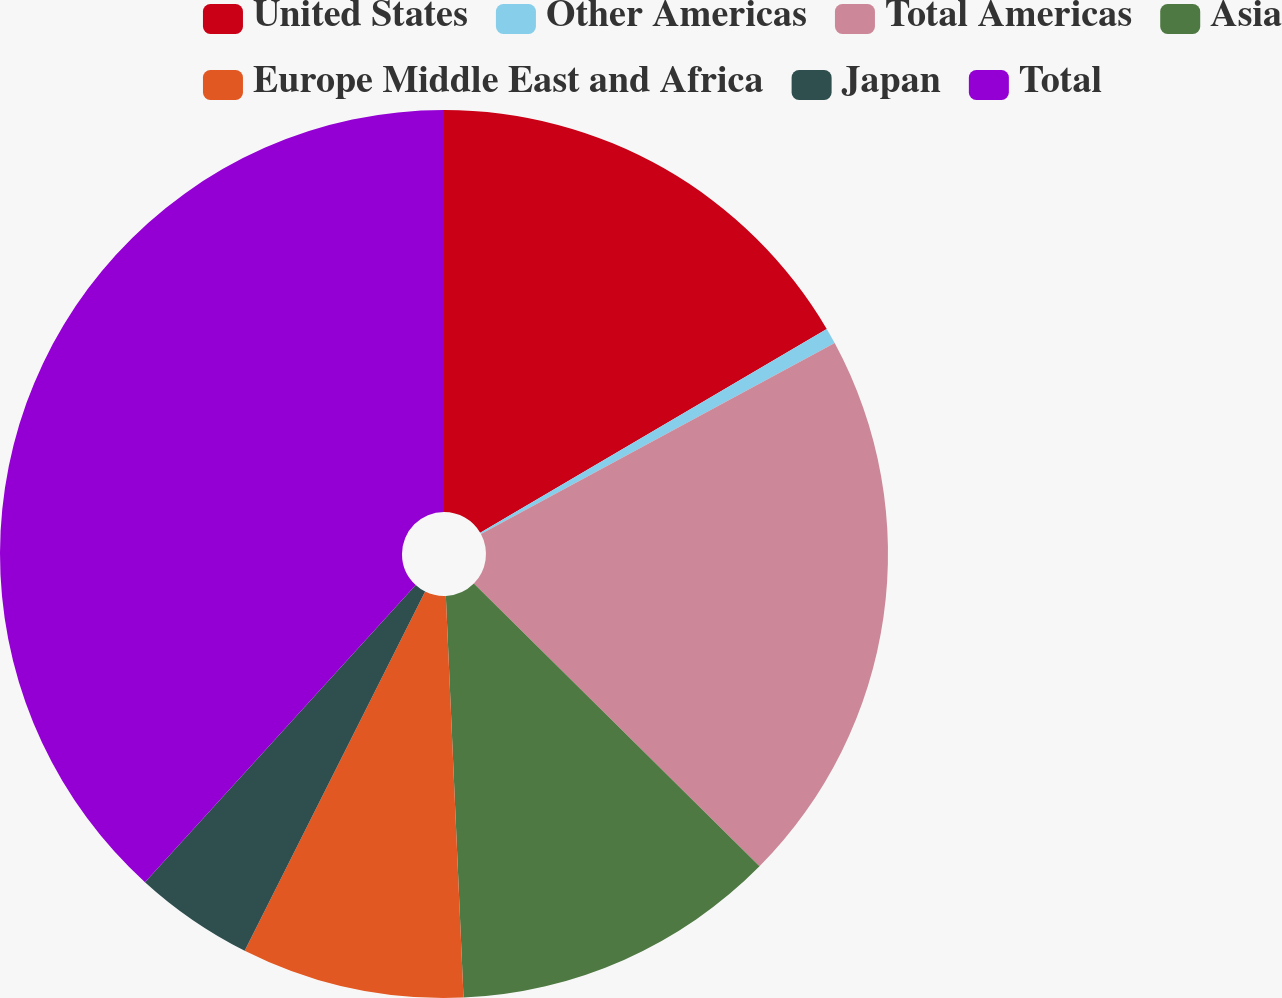<chart> <loc_0><loc_0><loc_500><loc_500><pie_chart><fcel>United States<fcel>Other Americas<fcel>Total Americas<fcel>Asia<fcel>Europe Middle East and Africa<fcel>Japan<fcel>Total<nl><fcel>16.54%<fcel>0.58%<fcel>20.3%<fcel>11.88%<fcel>8.11%<fcel>4.35%<fcel>38.24%<nl></chart> 